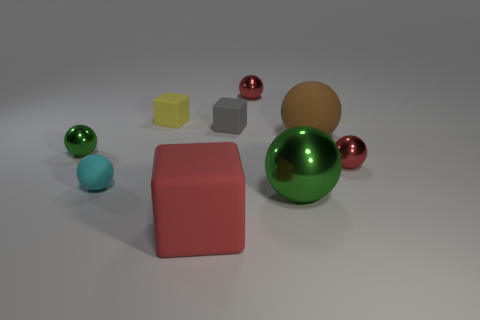Add 1 small purple matte spheres. How many objects exist? 10 Subtract all big red cubes. How many cubes are left? 2 Subtract all red cubes. How many red balls are left? 2 Subtract all cyan spheres. How many spheres are left? 5 Subtract 2 spheres. How many spheres are left? 4 Add 1 big red objects. How many big red objects exist? 2 Subtract 0 green cylinders. How many objects are left? 9 Subtract all spheres. How many objects are left? 3 Subtract all yellow cubes. Subtract all cyan cylinders. How many cubes are left? 2 Subtract all red cubes. Subtract all large matte blocks. How many objects are left? 7 